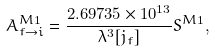Convert formula to latex. <formula><loc_0><loc_0><loc_500><loc_500>A ^ { M 1 } _ { f \rightarrow i } = \frac { 2 . 6 9 7 3 5 \times 1 0 ^ { 1 3 } } { \lambda ^ { 3 } [ j _ { f } ] } S ^ { M 1 } ,</formula> 